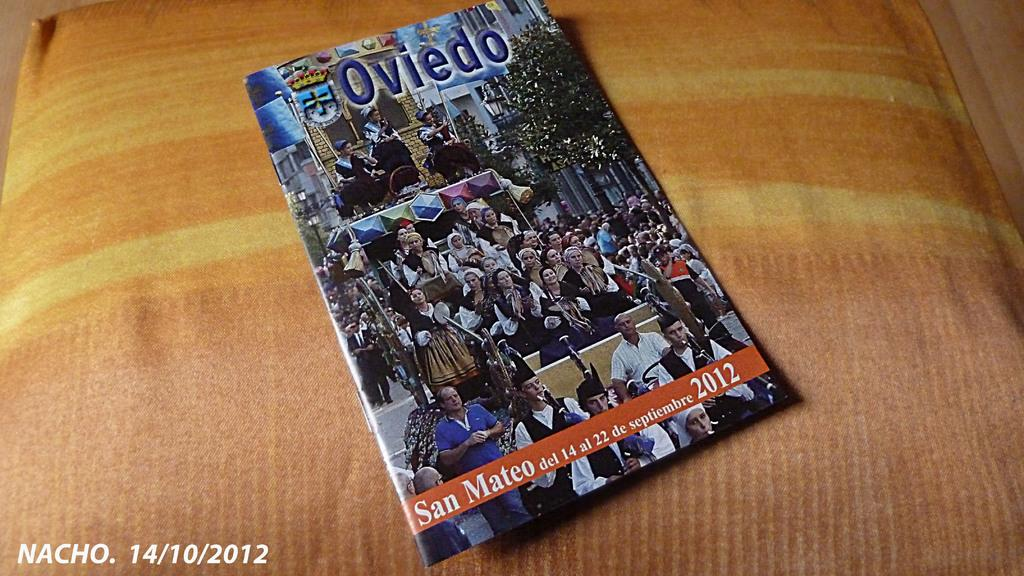What object is in the center of the image? There is a book in the center of the image. Where is the book placed? The book is placed on a pillow. What type of disease is mentioned in the book in the image? There is no mention of any disease in the image, as it only features a book placed on a pillow. 